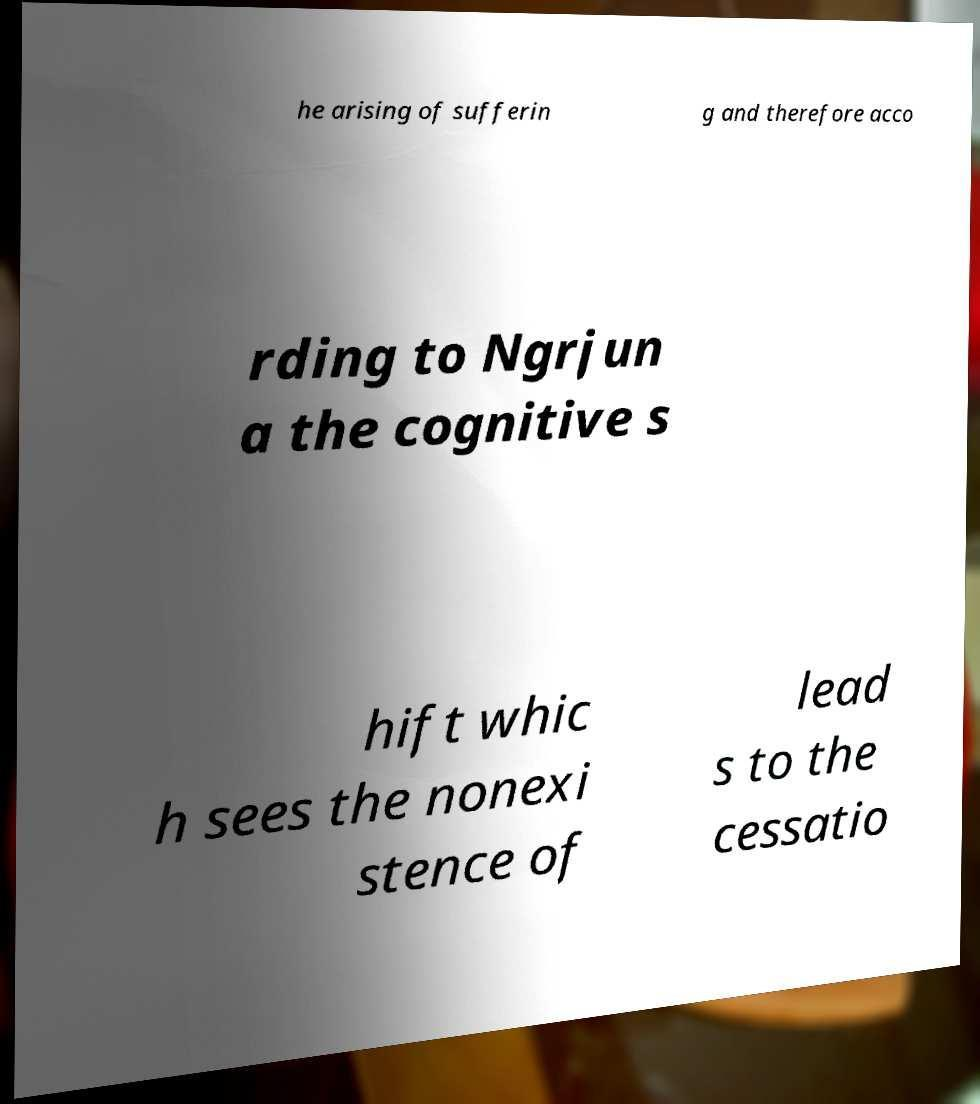I need the written content from this picture converted into text. Can you do that? he arising of sufferin g and therefore acco rding to Ngrjun a the cognitive s hift whic h sees the nonexi stence of lead s to the cessatio 